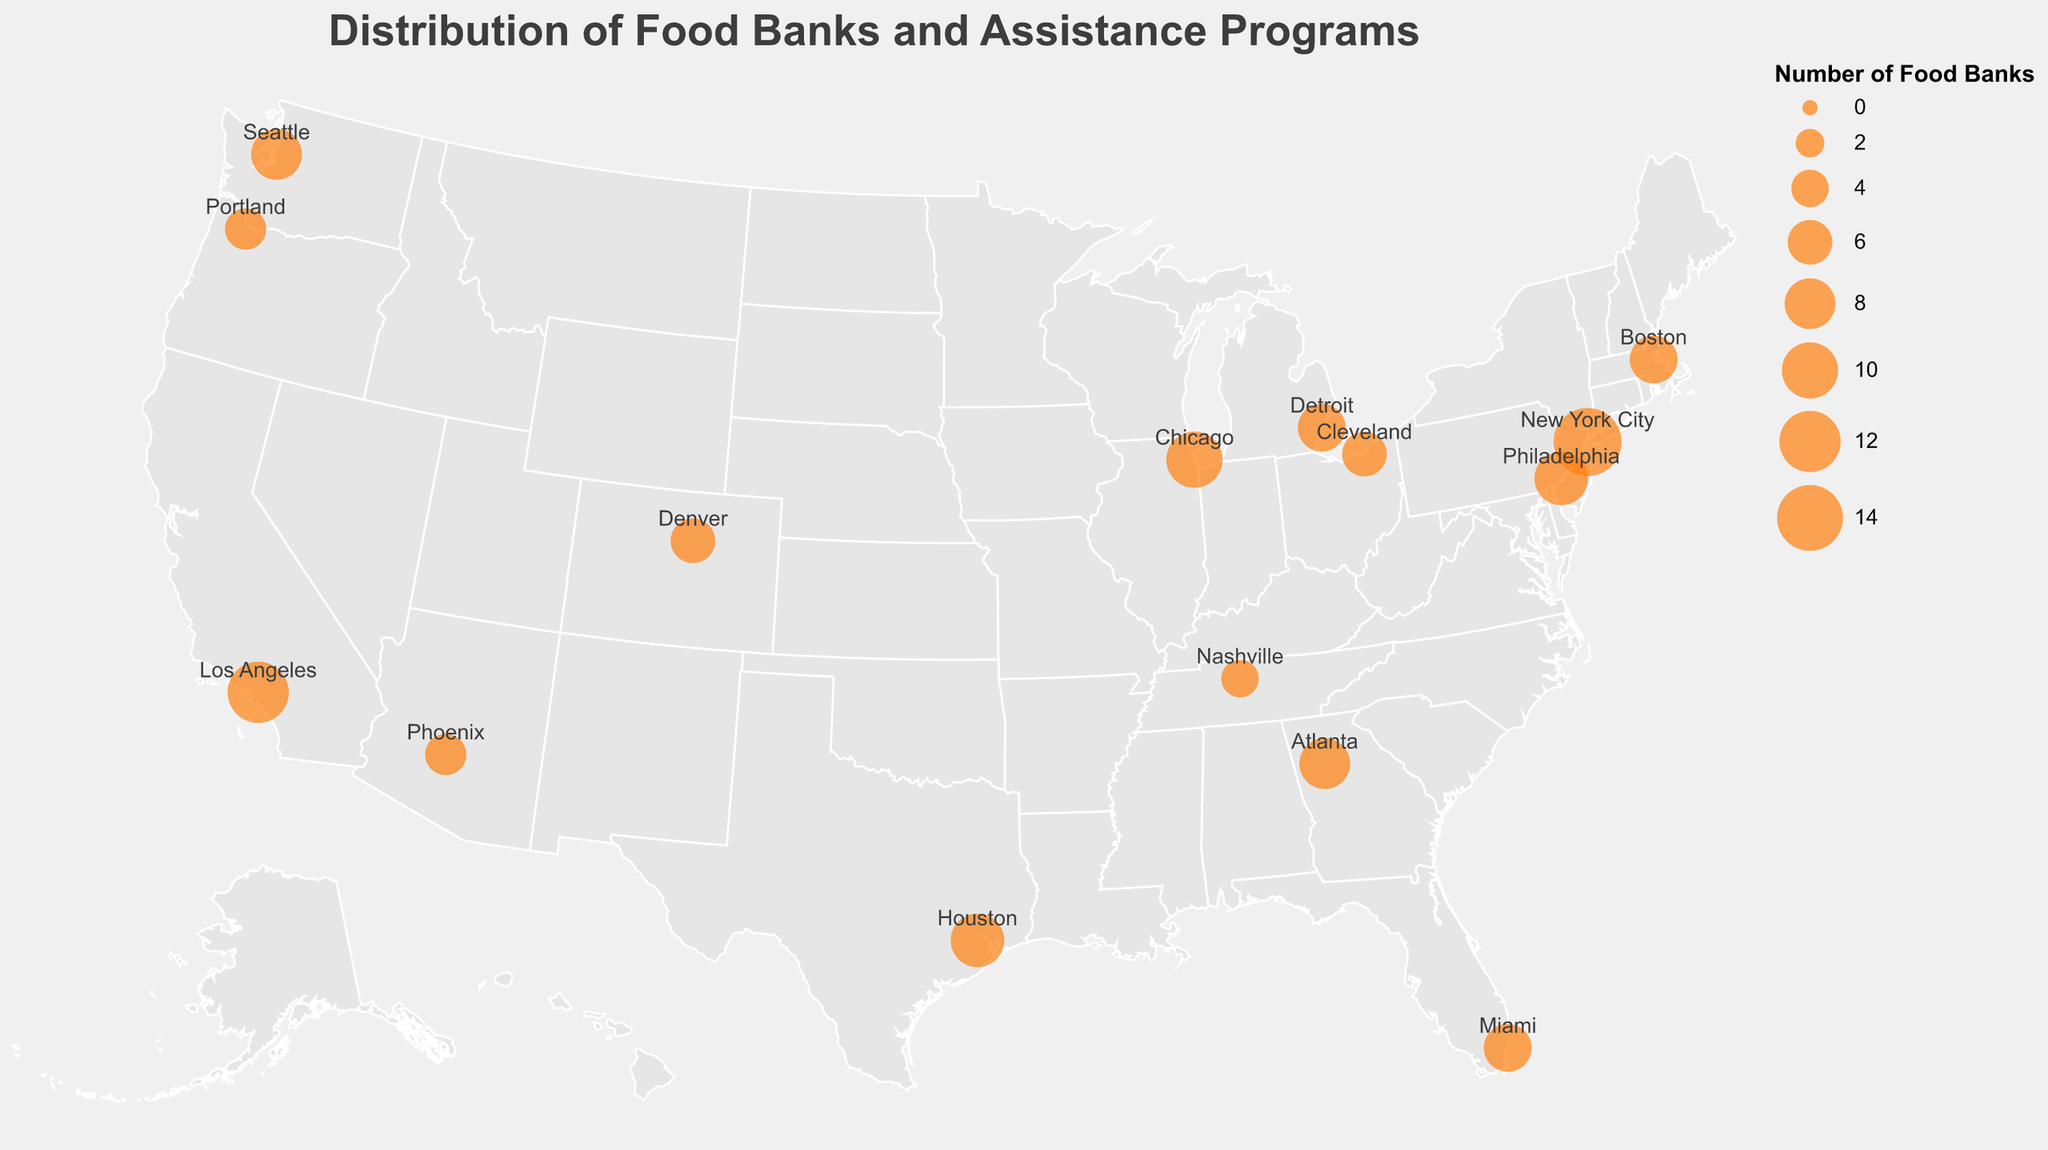What is the title of the plot? The title is located at the top of the plot and is typically larger and bold compared to other text in the plot.
Answer: Distribution of Food Banks and Assistance Programs How many cities are plotted in the figure? Count the number of city names labeled on the plot. Each city has a corresponding food bank and assistance program markers.
Answer: 15 Which city in California has the highest number of food banks? Locate California on the map and identify the city plotted. The tooltip or marker size represents the number of food banks.
Answer: Los Angeles What is the number of assistance programs in New York City? Hover over or refer to the New York City marker, which shows a tooltip containing the number of assistance programs.
Answer: 32 Which city has the highest poverty rate? Compare the poverty rates in the tooltips for each city, and identify the one with the highest value.
Answer: Detroit What is the total number of food banks in Texas? Refer to the marker in Texas for Houston and read the number from the tooltip or marker.
Answer: 9 Compare the number of assistance programs between Miami and Philadelphia. Which city has more? Read the respective values from the tooltips of Miami and Philadelphia and compare them.
Answer: Philadelphia What is the total number of assistance programs in cities with a poverty rate above 20%? Sum the assistance programs from cities with a poverty rate higher than 20%: Houston (22), Atlanta (20), Cleveland (15), Detroit (17), Philadelphia (23). Total = 22 + 20 + 15 + 17 + 23 = 97.
Answer: 97 Which city in Colorado has food banks plotted and what is the poverty rate there? Locate Colorado on the map and identify the city and look at the tooltip for the poverty rate.
Answer: Denver, 11.5% Is there a correlation between the number of food banks and the poverty rate? Analyze the data points, comparing the number of food banks with the corresponding poverty rate for each city to see if there's a pattern.
Answer: Moderate correlation 